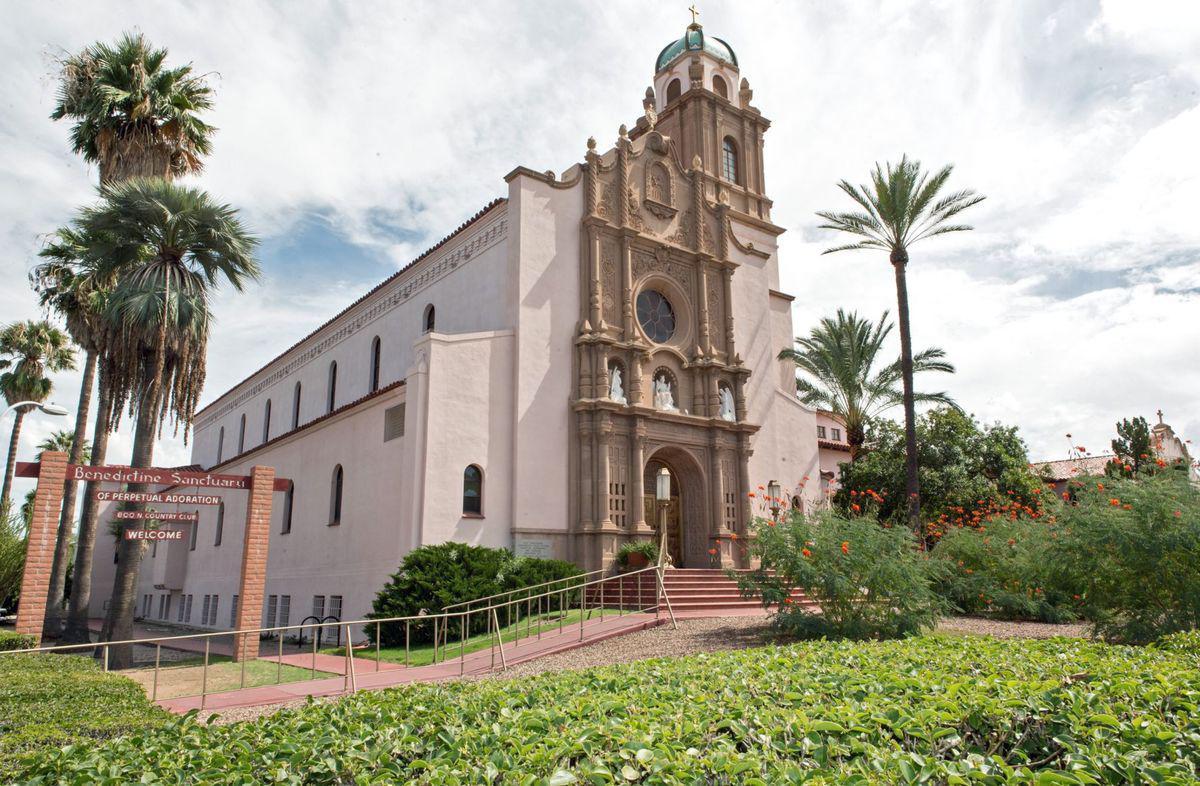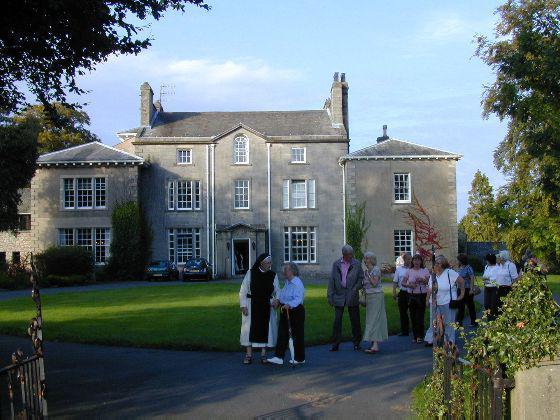The first image is the image on the left, the second image is the image on the right. For the images shown, is this caption "The building in the right image is yellow with a dark roof." true? Answer yes or no. No. 